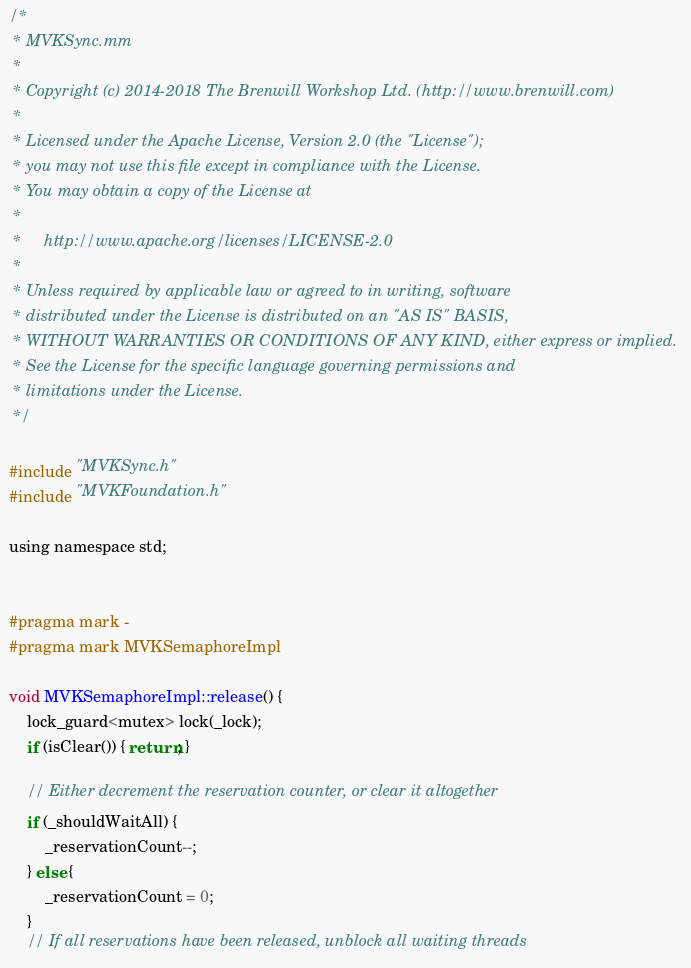Convert code to text. <code><loc_0><loc_0><loc_500><loc_500><_ObjectiveC_>/*
 * MVKSync.mm
 *
 * Copyright (c) 2014-2018 The Brenwill Workshop Ltd. (http://www.brenwill.com)
 *
 * Licensed under the Apache License, Version 2.0 (the "License");
 * you may not use this file except in compliance with the License.
 * You may obtain a copy of the License at
 * 
 *     http://www.apache.org/licenses/LICENSE-2.0
 * 
 * Unless required by applicable law or agreed to in writing, software
 * distributed under the License is distributed on an "AS IS" BASIS,
 * WITHOUT WARRANTIES OR CONDITIONS OF ANY KIND, either express or implied.
 * See the License for the specific language governing permissions and
 * limitations under the License.
 */

#include "MVKSync.h"
#include "MVKFoundation.h"

using namespace std;


#pragma mark -
#pragma mark MVKSemaphoreImpl

void MVKSemaphoreImpl::release() {
	lock_guard<mutex> lock(_lock);
    if (isClear()) { return; }

    // Either decrement the reservation counter, or clear it altogether
    if (_shouldWaitAll) {
        _reservationCount--;
    } else {
        _reservationCount = 0;
    }
    // If all reservations have been released, unblock all waiting threads</code> 